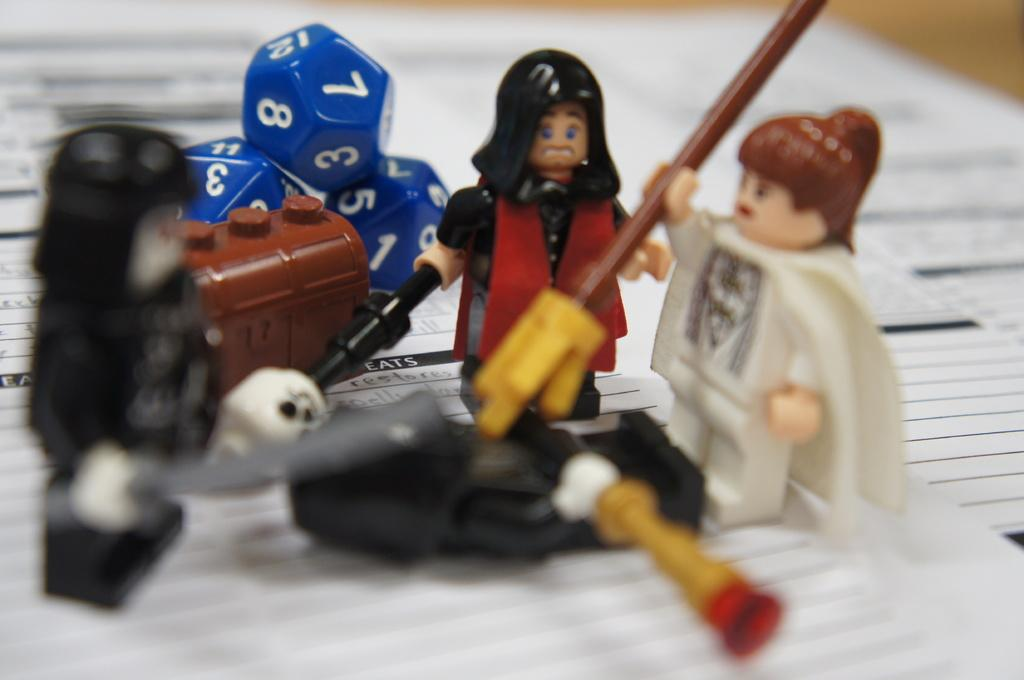What type of toys are present in the image? There are dolls in the image. What other objects can be seen on the left side of the image? There are hexagonal balls in blue color on the left side of the image. What type of honey is being served in the image? There is no honey present in the image. How many chairs are visible in the image? There are no chairs visible in the image. 